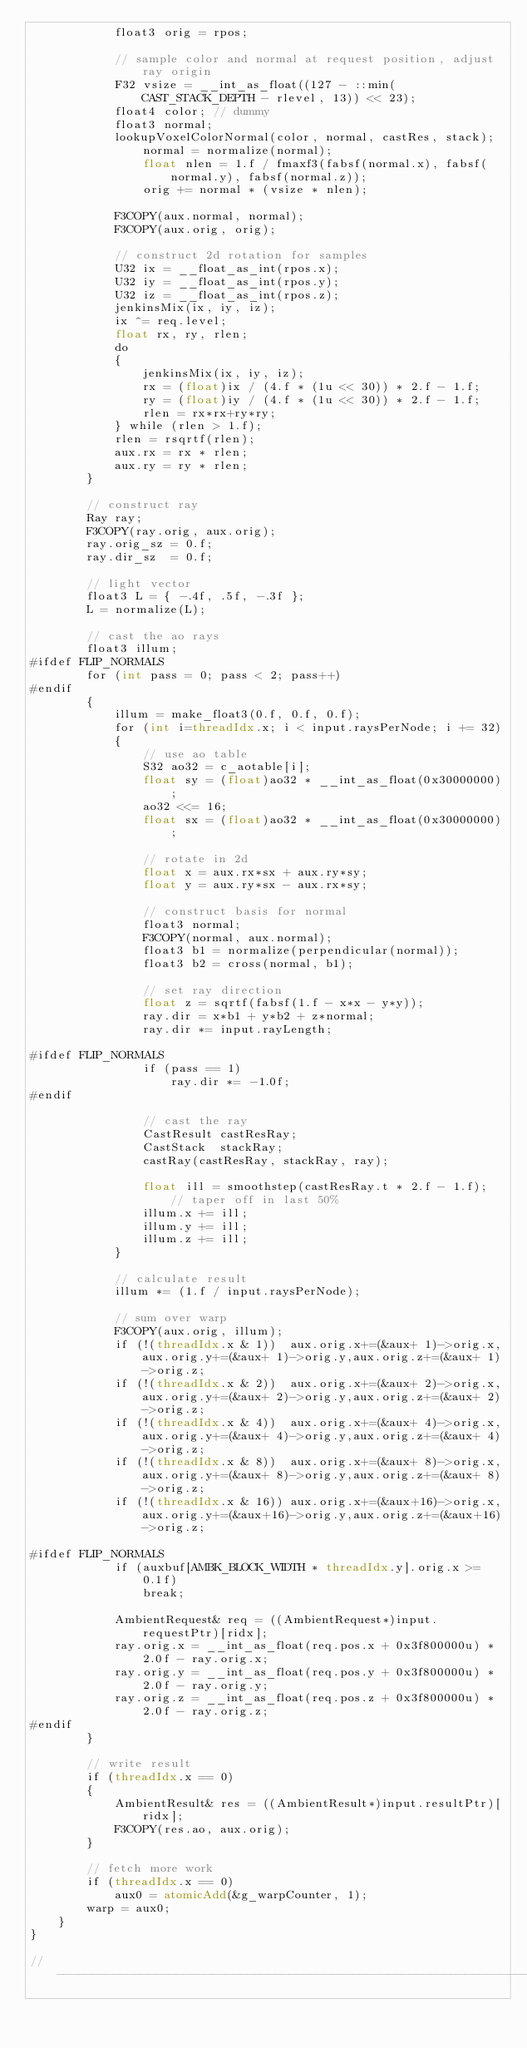Convert code to text. <code><loc_0><loc_0><loc_500><loc_500><_Cuda_>            float3 orig = rpos;

            // sample color and normal at request position, adjust ray origin
            F32 vsize = __int_as_float((127 - ::min(CAST_STACK_DEPTH - rlevel, 13)) << 23);
            float4 color; // dummy
            float3 normal;
            lookupVoxelColorNormal(color, normal, castRes, stack);
                normal = normalize(normal);
                float nlen = 1.f / fmaxf3(fabsf(normal.x), fabsf(normal.y), fabsf(normal.z));
                orig += normal * (vsize * nlen);

            F3COPY(aux.normal, normal);
            F3COPY(aux.orig, orig);

            // construct 2d rotation for samples
            U32 ix = __float_as_int(rpos.x);
            U32 iy = __float_as_int(rpos.y);
            U32 iz = __float_as_int(rpos.z);
            jenkinsMix(ix, iy, iz);
            ix ^= req.level;
            float rx, ry, rlen;
            do
            {
                jenkinsMix(ix, iy, iz);
                rx = (float)ix / (4.f * (1u << 30)) * 2.f - 1.f;
                ry = (float)iy / (4.f * (1u << 30)) * 2.f - 1.f;
                rlen = rx*rx+ry*ry;
            } while (rlen > 1.f);
            rlen = rsqrtf(rlen);
            aux.rx = rx * rlen;
            aux.ry = ry * rlen;
        }

        // construct ray
        Ray ray;
        F3COPY(ray.orig, aux.orig);
        ray.orig_sz = 0.f;
        ray.dir_sz  = 0.f;

        // light vector
        float3 L = { -.4f, .5f, -.3f };
        L = normalize(L);

        // cast the ao rays
        float3 illum;
#ifdef FLIP_NORMALS
        for (int pass = 0; pass < 2; pass++)
#endif
        {
            illum = make_float3(0.f, 0.f, 0.f);
            for (int i=threadIdx.x; i < input.raysPerNode; i += 32)
            {
                // use ao table
                S32 ao32 = c_aotable[i];
                float sy = (float)ao32 * __int_as_float(0x30000000);
                ao32 <<= 16;
                float sx = (float)ao32 * __int_as_float(0x30000000);

                // rotate in 2d
                float x = aux.rx*sx + aux.ry*sy;
                float y = aux.ry*sx - aux.rx*sy;

                // construct basis for normal
                float3 normal;
                F3COPY(normal, aux.normal);
                float3 b1 = normalize(perpendicular(normal));
                float3 b2 = cross(normal, b1);

                // set ray direction
                float z = sqrtf(fabsf(1.f - x*x - y*y));
                ray.dir = x*b1 + y*b2 + z*normal;
                ray.dir *= input.rayLength;

#ifdef FLIP_NORMALS
                if (pass == 1)
                    ray.dir *= -1.0f;
#endif

                // cast the ray
                CastResult castResRay;
                CastStack  stackRay;
                castRay(castResRay, stackRay, ray);

                float ill = smoothstep(castResRay.t * 2.f - 1.f); // taper off in last 50%
                illum.x += ill;
                illum.y += ill;
                illum.z += ill;
            }

            // calculate result
            illum *= (1.f / input.raysPerNode);

            // sum over warp
            F3COPY(aux.orig, illum);
            if (!(threadIdx.x & 1))  aux.orig.x+=(&aux+ 1)->orig.x,aux.orig.y+=(&aux+ 1)->orig.y,aux.orig.z+=(&aux+ 1)->orig.z;
            if (!(threadIdx.x & 2))  aux.orig.x+=(&aux+ 2)->orig.x,aux.orig.y+=(&aux+ 2)->orig.y,aux.orig.z+=(&aux+ 2)->orig.z;
            if (!(threadIdx.x & 4))  aux.orig.x+=(&aux+ 4)->orig.x,aux.orig.y+=(&aux+ 4)->orig.y,aux.orig.z+=(&aux+ 4)->orig.z;
            if (!(threadIdx.x & 8))  aux.orig.x+=(&aux+ 8)->orig.x,aux.orig.y+=(&aux+ 8)->orig.y,aux.orig.z+=(&aux+ 8)->orig.z;
            if (!(threadIdx.x & 16)) aux.orig.x+=(&aux+16)->orig.x,aux.orig.y+=(&aux+16)->orig.y,aux.orig.z+=(&aux+16)->orig.z;

#ifdef FLIP_NORMALS
            if (auxbuf[AMBK_BLOCK_WIDTH * threadIdx.y].orig.x >= 0.1f)
                break;

            AmbientRequest& req = ((AmbientRequest*)input.requestPtr)[ridx];
            ray.orig.x = __int_as_float(req.pos.x + 0x3f800000u) * 2.0f - ray.orig.x;
            ray.orig.y = __int_as_float(req.pos.y + 0x3f800000u) * 2.0f - ray.orig.y;
            ray.orig.z = __int_as_float(req.pos.z + 0x3f800000u) * 2.0f - ray.orig.z;
#endif
        }

        // write result
        if (threadIdx.x == 0)
        {
            AmbientResult& res = ((AmbientResult*)input.resultPtr)[ridx];
            F3COPY(res.ao, aux.orig);
        }

        // fetch more work
        if (threadIdx.x == 0)
            aux0 = atomicAdd(&g_warpCounter, 1);
        warp = aux0;
    }
}

//------------------------------------------------------------------------
</code> 